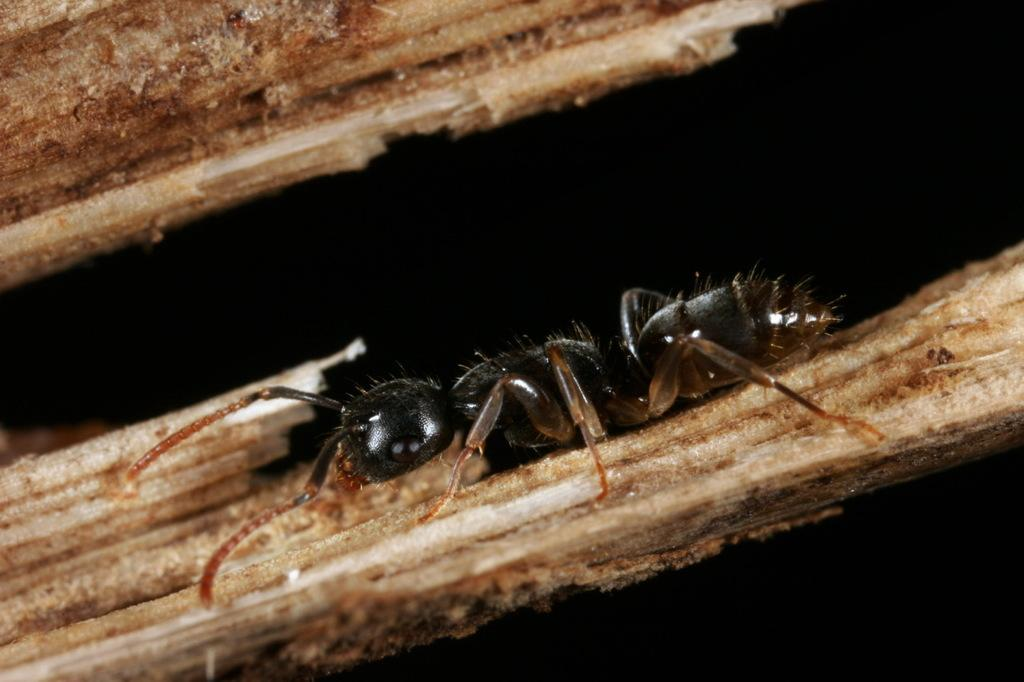What is the main subject of the image? The main subject of the image is an ant. What can be observed about the background of the image? The background of the image is dark. What type of coat is the father wearing in the image? There is no father or coat present in the image; it features an ant with a dark background. 